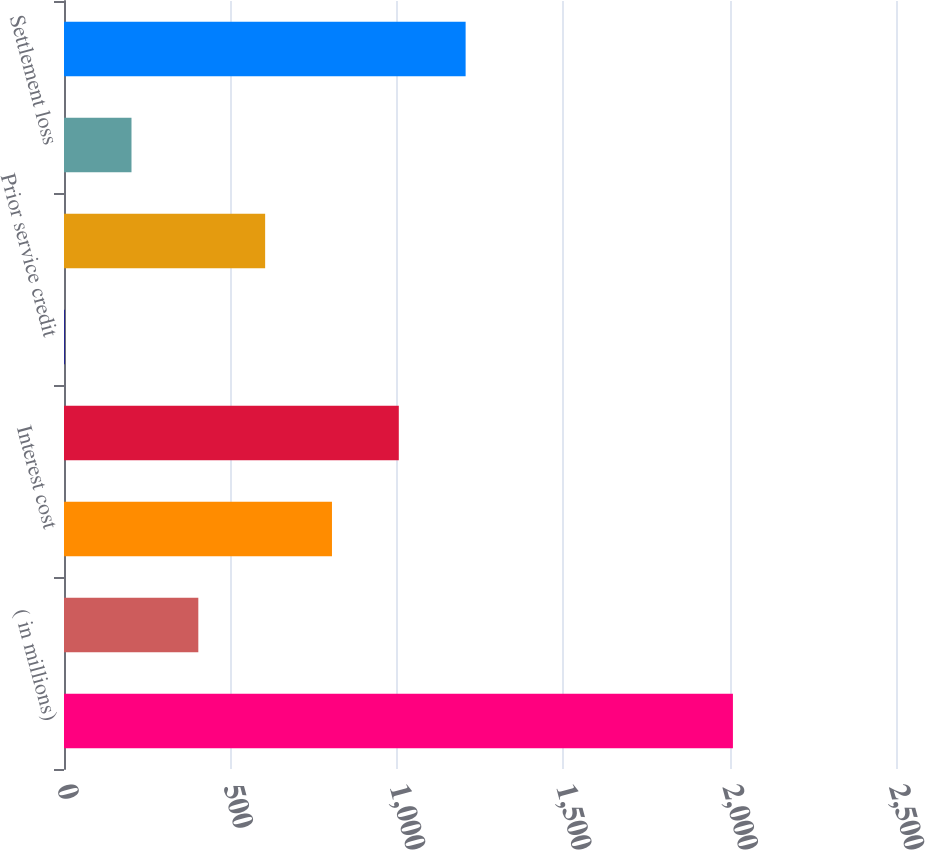<chart> <loc_0><loc_0><loc_500><loc_500><bar_chart><fcel>( in millions)<fcel>Service cost<fcel>Interest cost<fcel>Expected return on plan assets<fcel>Prior service credit<fcel>Net actuarial loss<fcel>Settlement loss<fcel>Net periodic cost<nl><fcel>2010<fcel>403.6<fcel>805.2<fcel>1006<fcel>2<fcel>604.4<fcel>202.8<fcel>1206.8<nl></chart> 